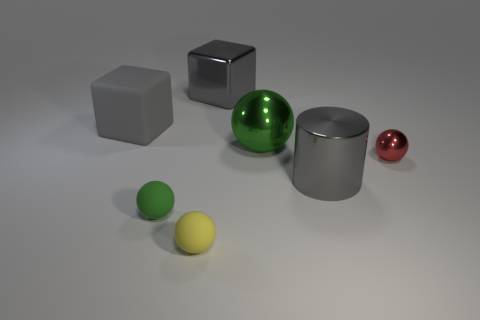There is a matte thing that is behind the small red metallic thing; is there a gray metal object that is in front of it?
Keep it short and to the point. Yes. What number of large gray things are behind the red metal ball and right of the yellow matte ball?
Offer a very short reply. 1. There is a thing that is on the right side of the big gray metallic cylinder; what is its shape?
Your answer should be compact. Sphere. What number of green metallic balls are the same size as the gray rubber object?
Your response must be concise. 1. Is the color of the object to the left of the tiny green matte sphere the same as the shiny cylinder?
Keep it short and to the point. Yes. There is a small ball that is behind the tiny yellow sphere and in front of the small red metal thing; what material is it?
Ensure brevity in your answer.  Rubber. Is the number of matte things greater than the number of large objects?
Keep it short and to the point. No. There is a tiny metallic ball that is on the right side of the cube that is on the right side of the cube to the left of the tiny yellow object; what color is it?
Your response must be concise. Red. Do the green sphere left of the big shiny cube and the yellow object have the same material?
Offer a terse response. Yes. Is there a cube that has the same color as the large cylinder?
Give a very brief answer. Yes. 